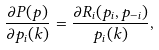Convert formula to latex. <formula><loc_0><loc_0><loc_500><loc_500>\frac { \partial P ( p ) } { \partial { { p } _ { i } } ( k ) } = \frac { \partial R _ { i } ( p _ { i } , p _ { - i } ) } { { { p } _ { i } } ( k ) } ,</formula> 